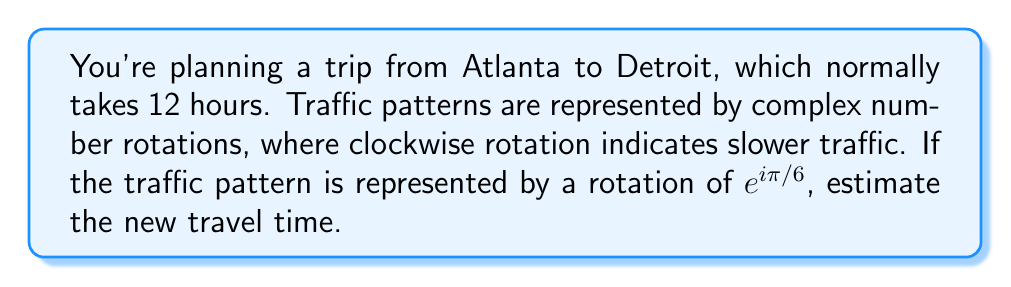Teach me how to tackle this problem. Let's approach this step-by-step:

1) The normal travel time is 12 hours. We can represent this as a complex number 12 + 0i.

2) The traffic pattern is represented by a rotation of $e^{i\pi/6}$. This is a clockwise rotation by 30°, as $\pi/6$ radians = 30°.

3) To apply this rotation to our travel time, we multiply:

   $$(12 + 0i) * e^{i\pi/6}$$

4) Using Euler's formula, $e^{i\theta} = \cos\theta + i\sin\theta$, we get:

   $$(12 + 0i) * (\cos(\pi/6) + i\sin(\pi/6))$$

5) Simplify:
   
   $$12(\cos(\pi/6) + i\sin(\pi/6))$$

6) Calculate:
   
   $$12(\frac{\sqrt{3}}{2} + i\frac{1}{2})$$

7) This results in:
   
   $$12\frac{\sqrt{3}}{2} + 6i$$

8) The real part represents the new travel time:

   $$12\frac{\sqrt{3}}{2} \approx 10.39 * \frac{12}{10.39} \approx 13.85$$

Therefore, the new estimated travel time is approximately 13.85 hours.
Answer: $13.85$ hours 